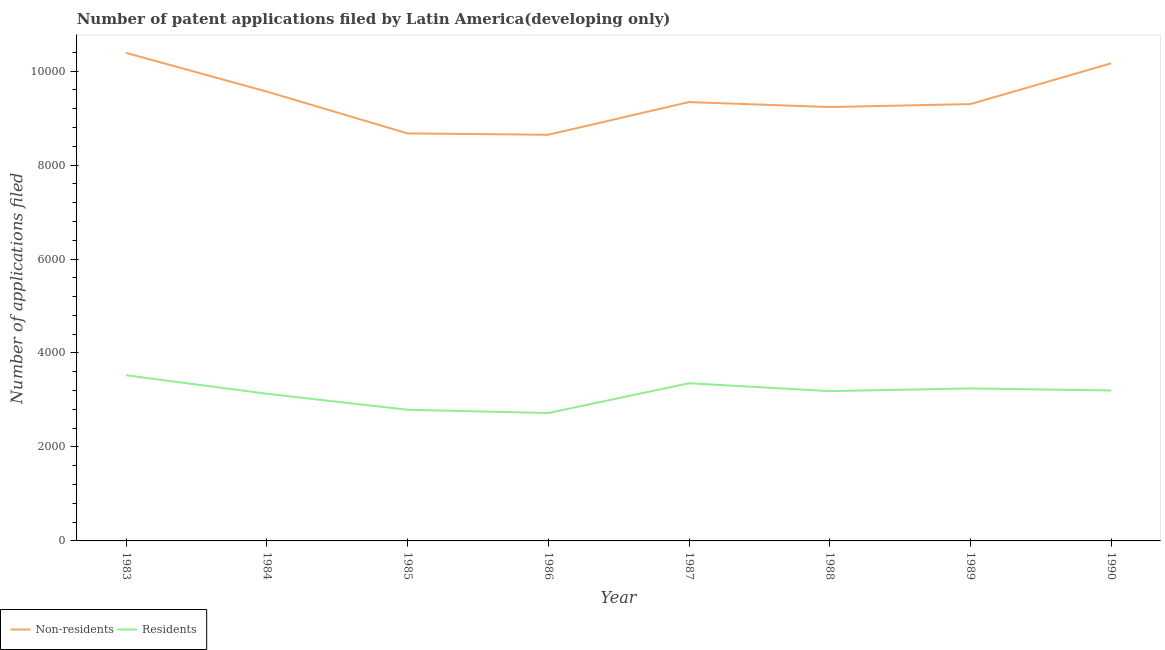How many different coloured lines are there?
Your answer should be compact. 2. Is the number of lines equal to the number of legend labels?
Your answer should be very brief. Yes. What is the number of patent applications by non residents in 1983?
Make the answer very short. 1.04e+04. Across all years, what is the maximum number of patent applications by residents?
Offer a very short reply. 3526. Across all years, what is the minimum number of patent applications by non residents?
Your answer should be compact. 8645. In which year was the number of patent applications by residents minimum?
Offer a terse response. 1986. What is the total number of patent applications by non residents in the graph?
Provide a succinct answer. 7.53e+04. What is the difference between the number of patent applications by non residents in 1986 and that in 1987?
Your answer should be very brief. -696. What is the difference between the number of patent applications by residents in 1985 and the number of patent applications by non residents in 1987?
Provide a short and direct response. -6549. What is the average number of patent applications by non residents per year?
Your answer should be very brief. 9414. In the year 1984, what is the difference between the number of patent applications by non residents and number of patent applications by residents?
Provide a short and direct response. 6432. What is the ratio of the number of patent applications by non residents in 1983 to that in 1984?
Offer a terse response. 1.09. What is the difference between the highest and the second highest number of patent applications by non residents?
Ensure brevity in your answer.  222. What is the difference between the highest and the lowest number of patent applications by residents?
Ensure brevity in your answer.  804. In how many years, is the number of patent applications by non residents greater than the average number of patent applications by non residents taken over all years?
Your response must be concise. 3. Is the sum of the number of patent applications by non residents in 1986 and 1987 greater than the maximum number of patent applications by residents across all years?
Offer a terse response. Yes. Does the number of patent applications by non residents monotonically increase over the years?
Offer a terse response. No. Is the number of patent applications by non residents strictly greater than the number of patent applications by residents over the years?
Your answer should be very brief. Yes. Are the values on the major ticks of Y-axis written in scientific E-notation?
Keep it short and to the point. No. Does the graph contain grids?
Offer a terse response. No. How many legend labels are there?
Make the answer very short. 2. What is the title of the graph?
Your answer should be compact. Number of patent applications filed by Latin America(developing only). What is the label or title of the X-axis?
Your answer should be very brief. Year. What is the label or title of the Y-axis?
Give a very brief answer. Number of applications filed. What is the Number of applications filed of Non-residents in 1983?
Ensure brevity in your answer.  1.04e+04. What is the Number of applications filed of Residents in 1983?
Provide a succinct answer. 3526. What is the Number of applications filed of Non-residents in 1984?
Provide a short and direct response. 9565. What is the Number of applications filed of Residents in 1984?
Ensure brevity in your answer.  3133. What is the Number of applications filed in Non-residents in 1985?
Your answer should be very brief. 8674. What is the Number of applications filed in Residents in 1985?
Offer a terse response. 2792. What is the Number of applications filed of Non-residents in 1986?
Give a very brief answer. 8645. What is the Number of applications filed of Residents in 1986?
Provide a succinct answer. 2722. What is the Number of applications filed of Non-residents in 1987?
Give a very brief answer. 9341. What is the Number of applications filed in Residents in 1987?
Offer a terse response. 3356. What is the Number of applications filed in Non-residents in 1988?
Provide a short and direct response. 9235. What is the Number of applications filed in Residents in 1988?
Your answer should be very brief. 3188. What is the Number of applications filed of Non-residents in 1989?
Ensure brevity in your answer.  9298. What is the Number of applications filed of Residents in 1989?
Your answer should be very brief. 3246. What is the Number of applications filed in Non-residents in 1990?
Your answer should be very brief. 1.02e+04. What is the Number of applications filed in Residents in 1990?
Make the answer very short. 3202. Across all years, what is the maximum Number of applications filed in Non-residents?
Keep it short and to the point. 1.04e+04. Across all years, what is the maximum Number of applications filed of Residents?
Make the answer very short. 3526. Across all years, what is the minimum Number of applications filed of Non-residents?
Ensure brevity in your answer.  8645. Across all years, what is the minimum Number of applications filed in Residents?
Keep it short and to the point. 2722. What is the total Number of applications filed of Non-residents in the graph?
Provide a short and direct response. 7.53e+04. What is the total Number of applications filed of Residents in the graph?
Provide a succinct answer. 2.52e+04. What is the difference between the Number of applications filed of Non-residents in 1983 and that in 1984?
Provide a short and direct response. 823. What is the difference between the Number of applications filed of Residents in 1983 and that in 1984?
Make the answer very short. 393. What is the difference between the Number of applications filed of Non-residents in 1983 and that in 1985?
Offer a very short reply. 1714. What is the difference between the Number of applications filed of Residents in 1983 and that in 1985?
Offer a very short reply. 734. What is the difference between the Number of applications filed of Non-residents in 1983 and that in 1986?
Provide a short and direct response. 1743. What is the difference between the Number of applications filed of Residents in 1983 and that in 1986?
Provide a succinct answer. 804. What is the difference between the Number of applications filed of Non-residents in 1983 and that in 1987?
Ensure brevity in your answer.  1047. What is the difference between the Number of applications filed in Residents in 1983 and that in 1987?
Provide a short and direct response. 170. What is the difference between the Number of applications filed in Non-residents in 1983 and that in 1988?
Give a very brief answer. 1153. What is the difference between the Number of applications filed in Residents in 1983 and that in 1988?
Provide a succinct answer. 338. What is the difference between the Number of applications filed of Non-residents in 1983 and that in 1989?
Keep it short and to the point. 1090. What is the difference between the Number of applications filed of Residents in 1983 and that in 1989?
Provide a succinct answer. 280. What is the difference between the Number of applications filed of Non-residents in 1983 and that in 1990?
Your response must be concise. 222. What is the difference between the Number of applications filed of Residents in 1983 and that in 1990?
Ensure brevity in your answer.  324. What is the difference between the Number of applications filed in Non-residents in 1984 and that in 1985?
Provide a succinct answer. 891. What is the difference between the Number of applications filed of Residents in 1984 and that in 1985?
Keep it short and to the point. 341. What is the difference between the Number of applications filed of Non-residents in 1984 and that in 1986?
Your answer should be very brief. 920. What is the difference between the Number of applications filed in Residents in 1984 and that in 1986?
Offer a very short reply. 411. What is the difference between the Number of applications filed in Non-residents in 1984 and that in 1987?
Make the answer very short. 224. What is the difference between the Number of applications filed of Residents in 1984 and that in 1987?
Give a very brief answer. -223. What is the difference between the Number of applications filed of Non-residents in 1984 and that in 1988?
Provide a succinct answer. 330. What is the difference between the Number of applications filed in Residents in 1984 and that in 1988?
Offer a very short reply. -55. What is the difference between the Number of applications filed of Non-residents in 1984 and that in 1989?
Offer a terse response. 267. What is the difference between the Number of applications filed in Residents in 1984 and that in 1989?
Your response must be concise. -113. What is the difference between the Number of applications filed of Non-residents in 1984 and that in 1990?
Your answer should be compact. -601. What is the difference between the Number of applications filed in Residents in 1984 and that in 1990?
Your response must be concise. -69. What is the difference between the Number of applications filed of Non-residents in 1985 and that in 1987?
Your response must be concise. -667. What is the difference between the Number of applications filed of Residents in 1985 and that in 1987?
Keep it short and to the point. -564. What is the difference between the Number of applications filed in Non-residents in 1985 and that in 1988?
Your answer should be compact. -561. What is the difference between the Number of applications filed in Residents in 1985 and that in 1988?
Offer a very short reply. -396. What is the difference between the Number of applications filed in Non-residents in 1985 and that in 1989?
Ensure brevity in your answer.  -624. What is the difference between the Number of applications filed in Residents in 1985 and that in 1989?
Keep it short and to the point. -454. What is the difference between the Number of applications filed in Non-residents in 1985 and that in 1990?
Your answer should be very brief. -1492. What is the difference between the Number of applications filed of Residents in 1985 and that in 1990?
Keep it short and to the point. -410. What is the difference between the Number of applications filed of Non-residents in 1986 and that in 1987?
Your answer should be very brief. -696. What is the difference between the Number of applications filed of Residents in 1986 and that in 1987?
Offer a terse response. -634. What is the difference between the Number of applications filed in Non-residents in 1986 and that in 1988?
Give a very brief answer. -590. What is the difference between the Number of applications filed in Residents in 1986 and that in 1988?
Give a very brief answer. -466. What is the difference between the Number of applications filed in Non-residents in 1986 and that in 1989?
Make the answer very short. -653. What is the difference between the Number of applications filed of Residents in 1986 and that in 1989?
Your answer should be compact. -524. What is the difference between the Number of applications filed in Non-residents in 1986 and that in 1990?
Provide a succinct answer. -1521. What is the difference between the Number of applications filed of Residents in 1986 and that in 1990?
Ensure brevity in your answer.  -480. What is the difference between the Number of applications filed of Non-residents in 1987 and that in 1988?
Your answer should be very brief. 106. What is the difference between the Number of applications filed in Residents in 1987 and that in 1988?
Ensure brevity in your answer.  168. What is the difference between the Number of applications filed in Residents in 1987 and that in 1989?
Give a very brief answer. 110. What is the difference between the Number of applications filed in Non-residents in 1987 and that in 1990?
Give a very brief answer. -825. What is the difference between the Number of applications filed of Residents in 1987 and that in 1990?
Make the answer very short. 154. What is the difference between the Number of applications filed in Non-residents in 1988 and that in 1989?
Provide a short and direct response. -63. What is the difference between the Number of applications filed of Residents in 1988 and that in 1989?
Your answer should be compact. -58. What is the difference between the Number of applications filed in Non-residents in 1988 and that in 1990?
Your response must be concise. -931. What is the difference between the Number of applications filed in Residents in 1988 and that in 1990?
Your answer should be very brief. -14. What is the difference between the Number of applications filed of Non-residents in 1989 and that in 1990?
Keep it short and to the point. -868. What is the difference between the Number of applications filed of Residents in 1989 and that in 1990?
Your answer should be compact. 44. What is the difference between the Number of applications filed in Non-residents in 1983 and the Number of applications filed in Residents in 1984?
Provide a short and direct response. 7255. What is the difference between the Number of applications filed in Non-residents in 1983 and the Number of applications filed in Residents in 1985?
Offer a very short reply. 7596. What is the difference between the Number of applications filed of Non-residents in 1983 and the Number of applications filed of Residents in 1986?
Offer a very short reply. 7666. What is the difference between the Number of applications filed of Non-residents in 1983 and the Number of applications filed of Residents in 1987?
Ensure brevity in your answer.  7032. What is the difference between the Number of applications filed of Non-residents in 1983 and the Number of applications filed of Residents in 1988?
Your answer should be compact. 7200. What is the difference between the Number of applications filed of Non-residents in 1983 and the Number of applications filed of Residents in 1989?
Provide a succinct answer. 7142. What is the difference between the Number of applications filed in Non-residents in 1983 and the Number of applications filed in Residents in 1990?
Provide a short and direct response. 7186. What is the difference between the Number of applications filed in Non-residents in 1984 and the Number of applications filed in Residents in 1985?
Offer a very short reply. 6773. What is the difference between the Number of applications filed of Non-residents in 1984 and the Number of applications filed of Residents in 1986?
Your answer should be very brief. 6843. What is the difference between the Number of applications filed of Non-residents in 1984 and the Number of applications filed of Residents in 1987?
Your answer should be very brief. 6209. What is the difference between the Number of applications filed of Non-residents in 1984 and the Number of applications filed of Residents in 1988?
Give a very brief answer. 6377. What is the difference between the Number of applications filed in Non-residents in 1984 and the Number of applications filed in Residents in 1989?
Offer a very short reply. 6319. What is the difference between the Number of applications filed in Non-residents in 1984 and the Number of applications filed in Residents in 1990?
Offer a very short reply. 6363. What is the difference between the Number of applications filed of Non-residents in 1985 and the Number of applications filed of Residents in 1986?
Provide a succinct answer. 5952. What is the difference between the Number of applications filed in Non-residents in 1985 and the Number of applications filed in Residents in 1987?
Keep it short and to the point. 5318. What is the difference between the Number of applications filed in Non-residents in 1985 and the Number of applications filed in Residents in 1988?
Offer a terse response. 5486. What is the difference between the Number of applications filed of Non-residents in 1985 and the Number of applications filed of Residents in 1989?
Make the answer very short. 5428. What is the difference between the Number of applications filed in Non-residents in 1985 and the Number of applications filed in Residents in 1990?
Ensure brevity in your answer.  5472. What is the difference between the Number of applications filed in Non-residents in 1986 and the Number of applications filed in Residents in 1987?
Provide a short and direct response. 5289. What is the difference between the Number of applications filed in Non-residents in 1986 and the Number of applications filed in Residents in 1988?
Offer a very short reply. 5457. What is the difference between the Number of applications filed of Non-residents in 1986 and the Number of applications filed of Residents in 1989?
Keep it short and to the point. 5399. What is the difference between the Number of applications filed of Non-residents in 1986 and the Number of applications filed of Residents in 1990?
Provide a succinct answer. 5443. What is the difference between the Number of applications filed of Non-residents in 1987 and the Number of applications filed of Residents in 1988?
Make the answer very short. 6153. What is the difference between the Number of applications filed of Non-residents in 1987 and the Number of applications filed of Residents in 1989?
Your response must be concise. 6095. What is the difference between the Number of applications filed in Non-residents in 1987 and the Number of applications filed in Residents in 1990?
Provide a short and direct response. 6139. What is the difference between the Number of applications filed of Non-residents in 1988 and the Number of applications filed of Residents in 1989?
Keep it short and to the point. 5989. What is the difference between the Number of applications filed in Non-residents in 1988 and the Number of applications filed in Residents in 1990?
Provide a short and direct response. 6033. What is the difference between the Number of applications filed in Non-residents in 1989 and the Number of applications filed in Residents in 1990?
Offer a very short reply. 6096. What is the average Number of applications filed in Non-residents per year?
Provide a succinct answer. 9414. What is the average Number of applications filed in Residents per year?
Provide a short and direct response. 3145.62. In the year 1983, what is the difference between the Number of applications filed of Non-residents and Number of applications filed of Residents?
Offer a very short reply. 6862. In the year 1984, what is the difference between the Number of applications filed in Non-residents and Number of applications filed in Residents?
Offer a very short reply. 6432. In the year 1985, what is the difference between the Number of applications filed of Non-residents and Number of applications filed of Residents?
Ensure brevity in your answer.  5882. In the year 1986, what is the difference between the Number of applications filed of Non-residents and Number of applications filed of Residents?
Your answer should be compact. 5923. In the year 1987, what is the difference between the Number of applications filed in Non-residents and Number of applications filed in Residents?
Offer a very short reply. 5985. In the year 1988, what is the difference between the Number of applications filed of Non-residents and Number of applications filed of Residents?
Your answer should be compact. 6047. In the year 1989, what is the difference between the Number of applications filed of Non-residents and Number of applications filed of Residents?
Give a very brief answer. 6052. In the year 1990, what is the difference between the Number of applications filed in Non-residents and Number of applications filed in Residents?
Give a very brief answer. 6964. What is the ratio of the Number of applications filed in Non-residents in 1983 to that in 1984?
Your answer should be compact. 1.09. What is the ratio of the Number of applications filed of Residents in 1983 to that in 1984?
Your answer should be compact. 1.13. What is the ratio of the Number of applications filed in Non-residents in 1983 to that in 1985?
Make the answer very short. 1.2. What is the ratio of the Number of applications filed in Residents in 1983 to that in 1985?
Provide a succinct answer. 1.26. What is the ratio of the Number of applications filed in Non-residents in 1983 to that in 1986?
Make the answer very short. 1.2. What is the ratio of the Number of applications filed of Residents in 1983 to that in 1986?
Provide a short and direct response. 1.3. What is the ratio of the Number of applications filed in Non-residents in 1983 to that in 1987?
Your answer should be compact. 1.11. What is the ratio of the Number of applications filed in Residents in 1983 to that in 1987?
Make the answer very short. 1.05. What is the ratio of the Number of applications filed of Non-residents in 1983 to that in 1988?
Your answer should be compact. 1.12. What is the ratio of the Number of applications filed of Residents in 1983 to that in 1988?
Give a very brief answer. 1.11. What is the ratio of the Number of applications filed of Non-residents in 1983 to that in 1989?
Offer a very short reply. 1.12. What is the ratio of the Number of applications filed of Residents in 1983 to that in 1989?
Provide a succinct answer. 1.09. What is the ratio of the Number of applications filed of Non-residents in 1983 to that in 1990?
Your response must be concise. 1.02. What is the ratio of the Number of applications filed in Residents in 1983 to that in 1990?
Your answer should be compact. 1.1. What is the ratio of the Number of applications filed of Non-residents in 1984 to that in 1985?
Give a very brief answer. 1.1. What is the ratio of the Number of applications filed of Residents in 1984 to that in 1985?
Offer a very short reply. 1.12. What is the ratio of the Number of applications filed of Non-residents in 1984 to that in 1986?
Keep it short and to the point. 1.11. What is the ratio of the Number of applications filed in Residents in 1984 to that in 1986?
Give a very brief answer. 1.15. What is the ratio of the Number of applications filed of Residents in 1984 to that in 1987?
Your answer should be compact. 0.93. What is the ratio of the Number of applications filed in Non-residents in 1984 to that in 1988?
Give a very brief answer. 1.04. What is the ratio of the Number of applications filed of Residents in 1984 to that in 1988?
Provide a short and direct response. 0.98. What is the ratio of the Number of applications filed in Non-residents in 1984 to that in 1989?
Ensure brevity in your answer.  1.03. What is the ratio of the Number of applications filed in Residents in 1984 to that in 1989?
Offer a very short reply. 0.97. What is the ratio of the Number of applications filed of Non-residents in 1984 to that in 1990?
Provide a short and direct response. 0.94. What is the ratio of the Number of applications filed of Residents in 1984 to that in 1990?
Make the answer very short. 0.98. What is the ratio of the Number of applications filed in Residents in 1985 to that in 1986?
Offer a terse response. 1.03. What is the ratio of the Number of applications filed in Non-residents in 1985 to that in 1987?
Your response must be concise. 0.93. What is the ratio of the Number of applications filed of Residents in 1985 to that in 1987?
Give a very brief answer. 0.83. What is the ratio of the Number of applications filed in Non-residents in 1985 to that in 1988?
Make the answer very short. 0.94. What is the ratio of the Number of applications filed of Residents in 1985 to that in 1988?
Your response must be concise. 0.88. What is the ratio of the Number of applications filed in Non-residents in 1985 to that in 1989?
Your answer should be very brief. 0.93. What is the ratio of the Number of applications filed of Residents in 1985 to that in 1989?
Offer a terse response. 0.86. What is the ratio of the Number of applications filed of Non-residents in 1985 to that in 1990?
Offer a terse response. 0.85. What is the ratio of the Number of applications filed in Residents in 1985 to that in 1990?
Keep it short and to the point. 0.87. What is the ratio of the Number of applications filed of Non-residents in 1986 to that in 1987?
Provide a succinct answer. 0.93. What is the ratio of the Number of applications filed of Residents in 1986 to that in 1987?
Your answer should be very brief. 0.81. What is the ratio of the Number of applications filed of Non-residents in 1986 to that in 1988?
Keep it short and to the point. 0.94. What is the ratio of the Number of applications filed of Residents in 1986 to that in 1988?
Provide a succinct answer. 0.85. What is the ratio of the Number of applications filed in Non-residents in 1986 to that in 1989?
Offer a very short reply. 0.93. What is the ratio of the Number of applications filed in Residents in 1986 to that in 1989?
Provide a succinct answer. 0.84. What is the ratio of the Number of applications filed of Non-residents in 1986 to that in 1990?
Offer a very short reply. 0.85. What is the ratio of the Number of applications filed of Residents in 1986 to that in 1990?
Ensure brevity in your answer.  0.85. What is the ratio of the Number of applications filed of Non-residents in 1987 to that in 1988?
Your response must be concise. 1.01. What is the ratio of the Number of applications filed in Residents in 1987 to that in 1988?
Offer a terse response. 1.05. What is the ratio of the Number of applications filed in Residents in 1987 to that in 1989?
Your response must be concise. 1.03. What is the ratio of the Number of applications filed of Non-residents in 1987 to that in 1990?
Make the answer very short. 0.92. What is the ratio of the Number of applications filed of Residents in 1987 to that in 1990?
Provide a succinct answer. 1.05. What is the ratio of the Number of applications filed of Non-residents in 1988 to that in 1989?
Ensure brevity in your answer.  0.99. What is the ratio of the Number of applications filed in Residents in 1988 to that in 1989?
Your response must be concise. 0.98. What is the ratio of the Number of applications filed of Non-residents in 1988 to that in 1990?
Offer a terse response. 0.91. What is the ratio of the Number of applications filed of Non-residents in 1989 to that in 1990?
Provide a short and direct response. 0.91. What is the ratio of the Number of applications filed in Residents in 1989 to that in 1990?
Your answer should be compact. 1.01. What is the difference between the highest and the second highest Number of applications filed in Non-residents?
Your answer should be very brief. 222. What is the difference between the highest and the second highest Number of applications filed in Residents?
Offer a terse response. 170. What is the difference between the highest and the lowest Number of applications filed in Non-residents?
Your answer should be compact. 1743. What is the difference between the highest and the lowest Number of applications filed of Residents?
Your answer should be compact. 804. 